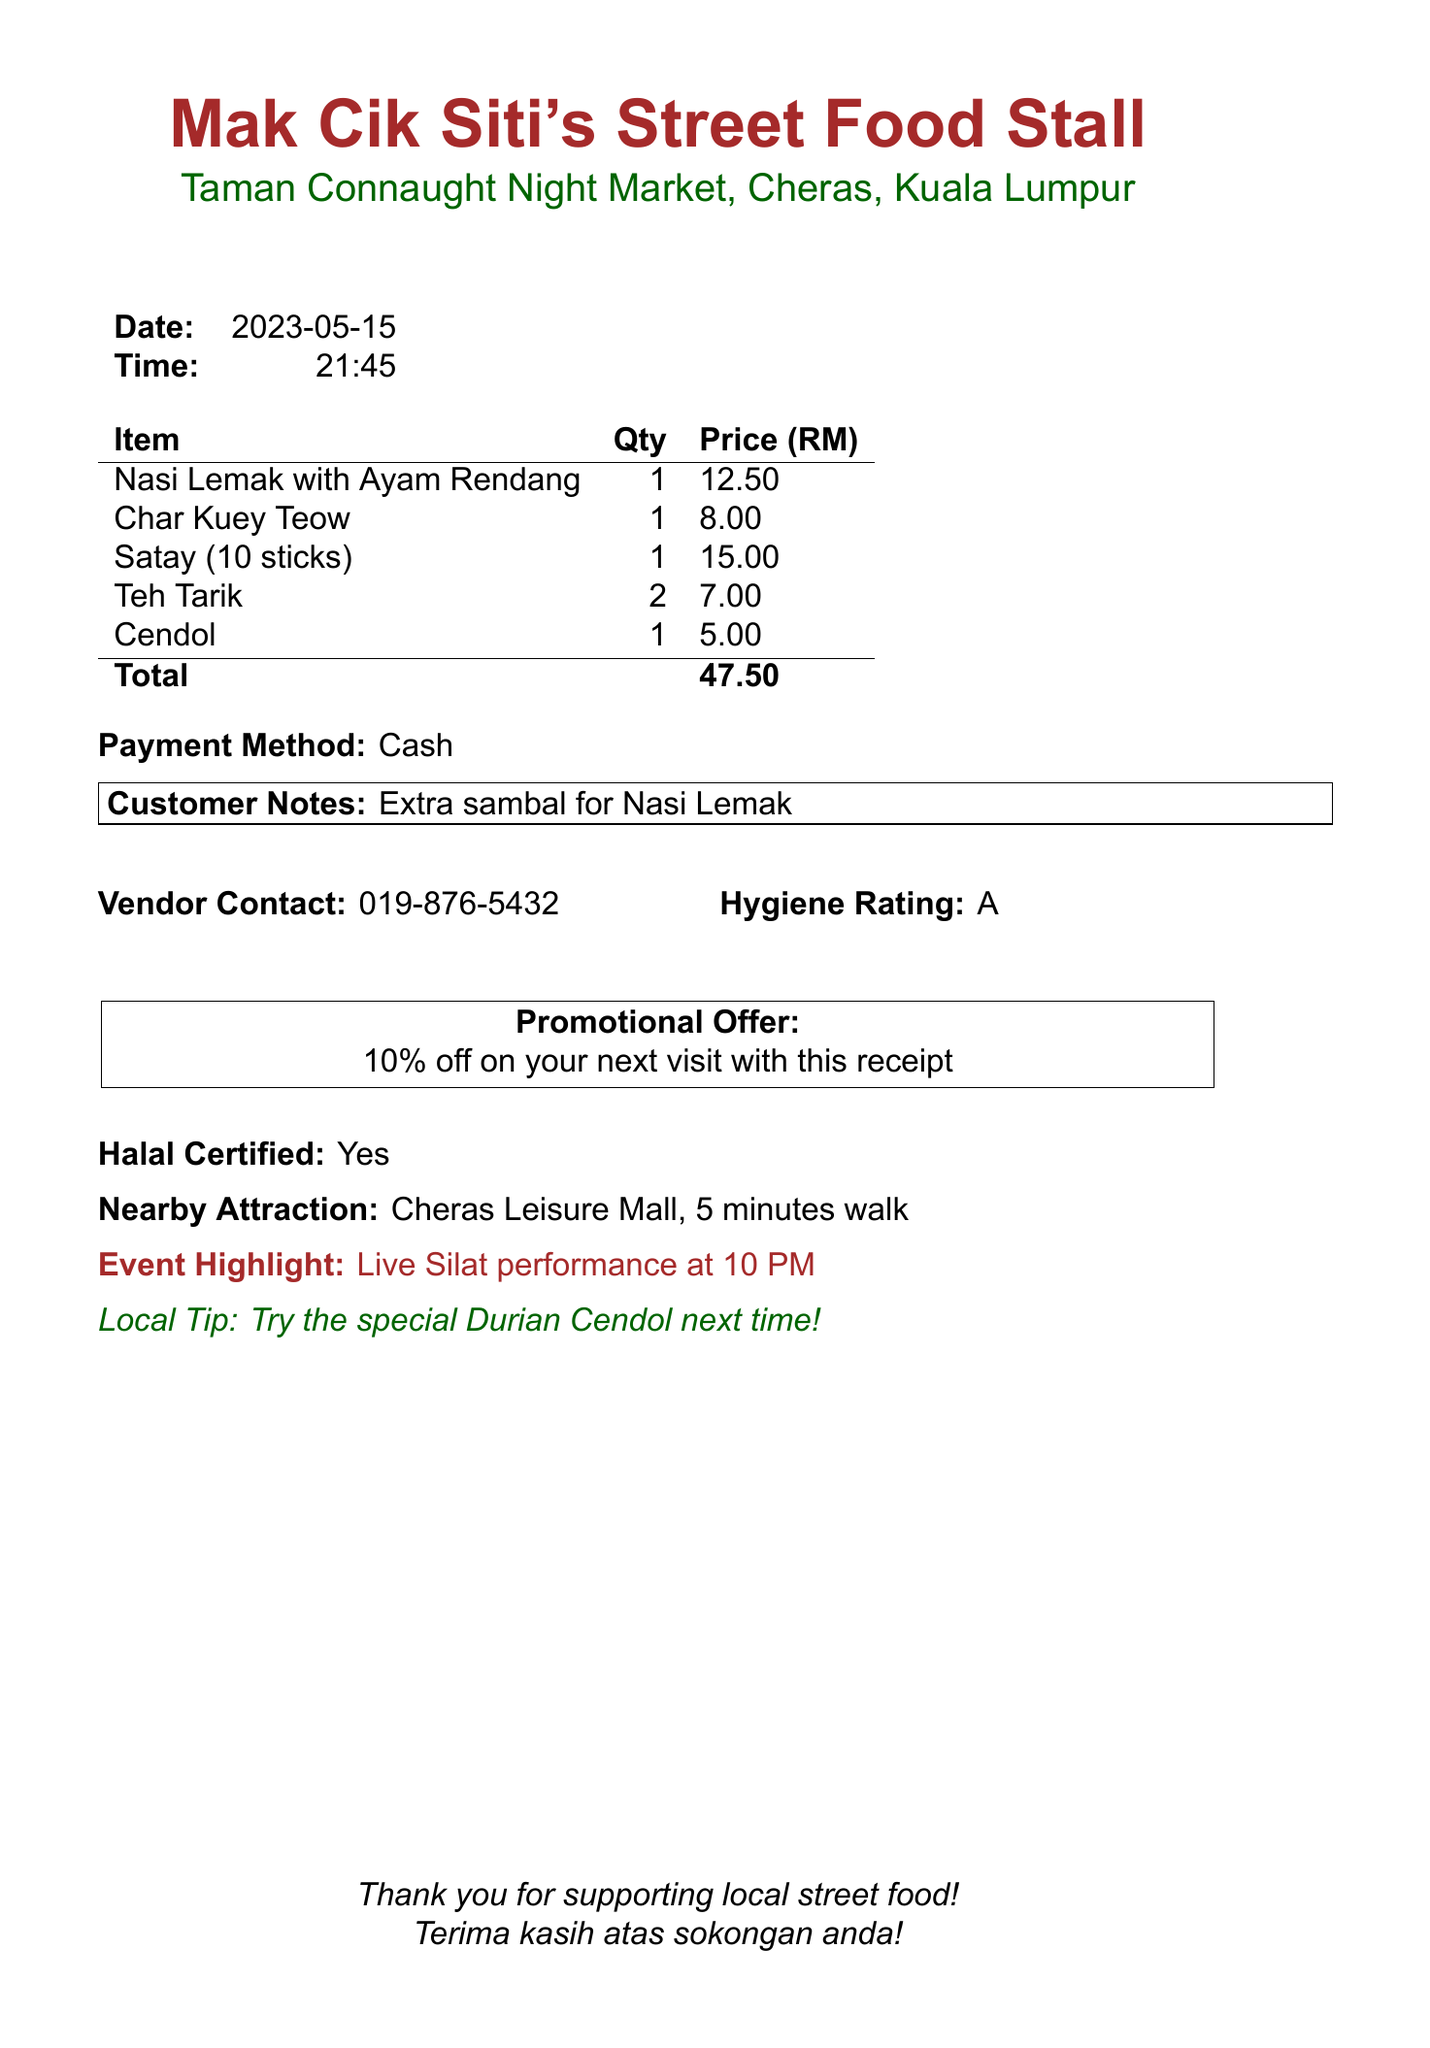What is the vendor's name? The vendor's name is prominently displayed at the top of the receipt.
Answer: Mak Cik Siti's Street Food Stall What is the total amount spent? The total amount is clearly stated in the document as the sum of all items purchased.
Answer: 47.50 What items were ordered? The receipt lists all the items ordered in a table format.
Answer: Nasi Lemak with Ayam Rendang, Char Kuey Teow, Satay (10 sticks), Teh Tarik, Cendol How many sticks of Satay were purchased? The description of the Satay item specifies the quantity of sticks purchased.
Answer: 10 sticks What time was the purchase made? The time of the transaction is noted in the document under the date section.
Answer: 21:45 What promotional offer is mentioned? The promotional offer is highlighted in a box on the document.
Answer: 10% off on your next visit with this receipt Is the food Halal certified? The document explicitly states this as part of the food safety information.
Answer: Yes What was the customer note? The customer notes section details any specific requests made during the purchase.
Answer: Extra sambal for Nasi Lemak What is the hygiene rating of the vendor? The hygiene rating is shown in the document and informs about food safety standards.
Answer: A 